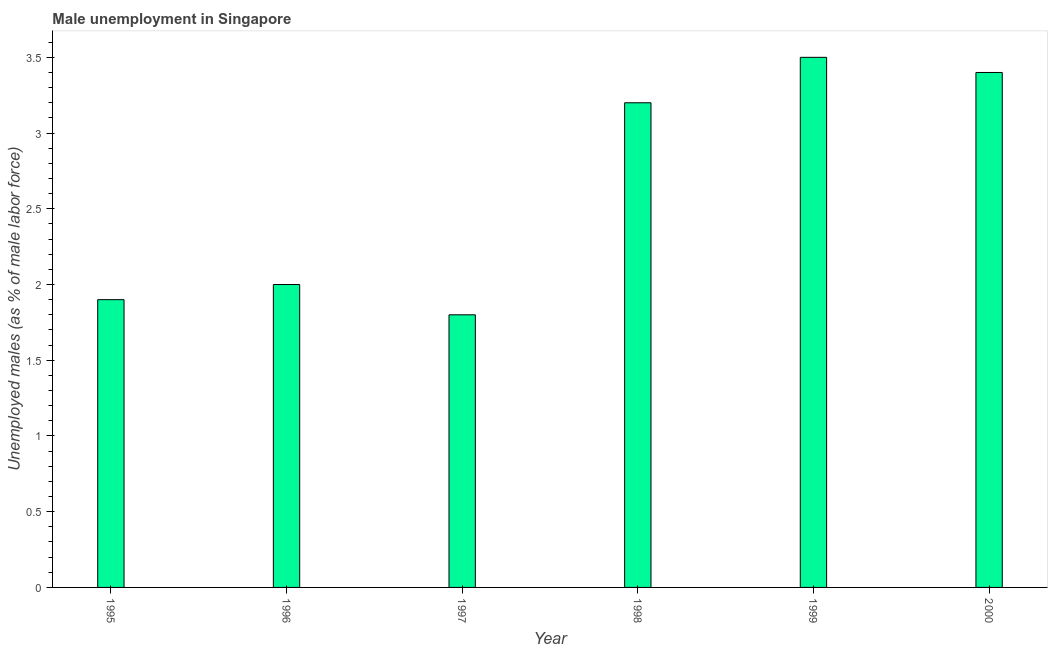What is the title of the graph?
Make the answer very short. Male unemployment in Singapore. What is the label or title of the X-axis?
Your answer should be compact. Year. What is the label or title of the Y-axis?
Keep it short and to the point. Unemployed males (as % of male labor force). Across all years, what is the minimum unemployed males population?
Give a very brief answer. 1.8. In which year was the unemployed males population maximum?
Keep it short and to the point. 1999. In which year was the unemployed males population minimum?
Provide a short and direct response. 1997. What is the sum of the unemployed males population?
Keep it short and to the point. 15.8. What is the average unemployed males population per year?
Make the answer very short. 2.63. What is the median unemployed males population?
Ensure brevity in your answer.  2.6. In how many years, is the unemployed males population greater than 3.3 %?
Give a very brief answer. 2. What is the ratio of the unemployed males population in 1996 to that in 1998?
Keep it short and to the point. 0.62. Is the difference between the unemployed males population in 1996 and 2000 greater than the difference between any two years?
Provide a succinct answer. No. What is the difference between the highest and the second highest unemployed males population?
Provide a succinct answer. 0.1. Is the sum of the unemployed males population in 1995 and 2000 greater than the maximum unemployed males population across all years?
Your answer should be compact. Yes. In how many years, is the unemployed males population greater than the average unemployed males population taken over all years?
Offer a terse response. 3. Are all the bars in the graph horizontal?
Your answer should be very brief. No. How many years are there in the graph?
Offer a very short reply. 6. Are the values on the major ticks of Y-axis written in scientific E-notation?
Ensure brevity in your answer.  No. What is the Unemployed males (as % of male labor force) of 1995?
Give a very brief answer. 1.9. What is the Unemployed males (as % of male labor force) in 1997?
Provide a short and direct response. 1.8. What is the Unemployed males (as % of male labor force) of 1998?
Provide a succinct answer. 3.2. What is the Unemployed males (as % of male labor force) of 2000?
Keep it short and to the point. 3.4. What is the difference between the Unemployed males (as % of male labor force) in 1995 and 1997?
Provide a short and direct response. 0.1. What is the difference between the Unemployed males (as % of male labor force) in 1995 and 2000?
Make the answer very short. -1.5. What is the difference between the Unemployed males (as % of male labor force) in 1996 and 1997?
Give a very brief answer. 0.2. What is the difference between the Unemployed males (as % of male labor force) in 1996 and 1999?
Offer a very short reply. -1.5. What is the difference between the Unemployed males (as % of male labor force) in 1996 and 2000?
Your response must be concise. -1.4. What is the difference between the Unemployed males (as % of male labor force) in 1997 and 1998?
Give a very brief answer. -1.4. What is the difference between the Unemployed males (as % of male labor force) in 1998 and 1999?
Make the answer very short. -0.3. What is the difference between the Unemployed males (as % of male labor force) in 1998 and 2000?
Provide a short and direct response. -0.2. What is the ratio of the Unemployed males (as % of male labor force) in 1995 to that in 1996?
Provide a short and direct response. 0.95. What is the ratio of the Unemployed males (as % of male labor force) in 1995 to that in 1997?
Provide a short and direct response. 1.06. What is the ratio of the Unemployed males (as % of male labor force) in 1995 to that in 1998?
Provide a succinct answer. 0.59. What is the ratio of the Unemployed males (as % of male labor force) in 1995 to that in 1999?
Make the answer very short. 0.54. What is the ratio of the Unemployed males (as % of male labor force) in 1995 to that in 2000?
Provide a short and direct response. 0.56. What is the ratio of the Unemployed males (as % of male labor force) in 1996 to that in 1997?
Your answer should be compact. 1.11. What is the ratio of the Unemployed males (as % of male labor force) in 1996 to that in 1998?
Offer a very short reply. 0.62. What is the ratio of the Unemployed males (as % of male labor force) in 1996 to that in 1999?
Make the answer very short. 0.57. What is the ratio of the Unemployed males (as % of male labor force) in 1996 to that in 2000?
Ensure brevity in your answer.  0.59. What is the ratio of the Unemployed males (as % of male labor force) in 1997 to that in 1998?
Provide a succinct answer. 0.56. What is the ratio of the Unemployed males (as % of male labor force) in 1997 to that in 1999?
Offer a terse response. 0.51. What is the ratio of the Unemployed males (as % of male labor force) in 1997 to that in 2000?
Provide a succinct answer. 0.53. What is the ratio of the Unemployed males (as % of male labor force) in 1998 to that in 1999?
Make the answer very short. 0.91. What is the ratio of the Unemployed males (as % of male labor force) in 1998 to that in 2000?
Your response must be concise. 0.94. What is the ratio of the Unemployed males (as % of male labor force) in 1999 to that in 2000?
Offer a terse response. 1.03. 